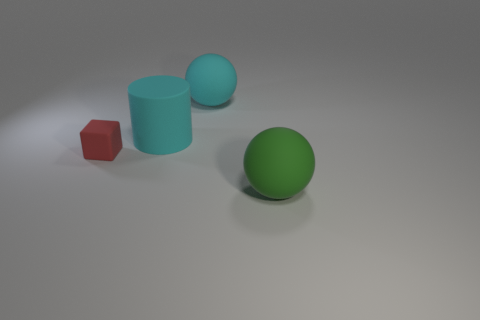Is there a object of the same color as the matte cylinder?
Offer a very short reply. Yes. What is the shape of the tiny red object?
Provide a short and direct response. Cube. What color is the large object that is left of the rubber thing behind the cyan matte cylinder?
Give a very brief answer. Cyan. How big is the red object that is on the left side of the large green sphere?
Provide a short and direct response. Small. Is there a large thing made of the same material as the tiny object?
Your answer should be very brief. Yes. How many small red things are the same shape as the big green rubber object?
Your answer should be compact. 0. There is a large matte object that is on the left side of the big rubber sphere behind the object on the right side of the cyan ball; what shape is it?
Offer a very short reply. Cylinder. There is a ball left of the green matte thing; is it the same size as the large green thing?
Keep it short and to the point. Yes. Is there anything else that has the same size as the red block?
Provide a succinct answer. No. Are there more tiny red objects in front of the tiny red cube than matte objects on the left side of the matte cylinder?
Your answer should be compact. No. 